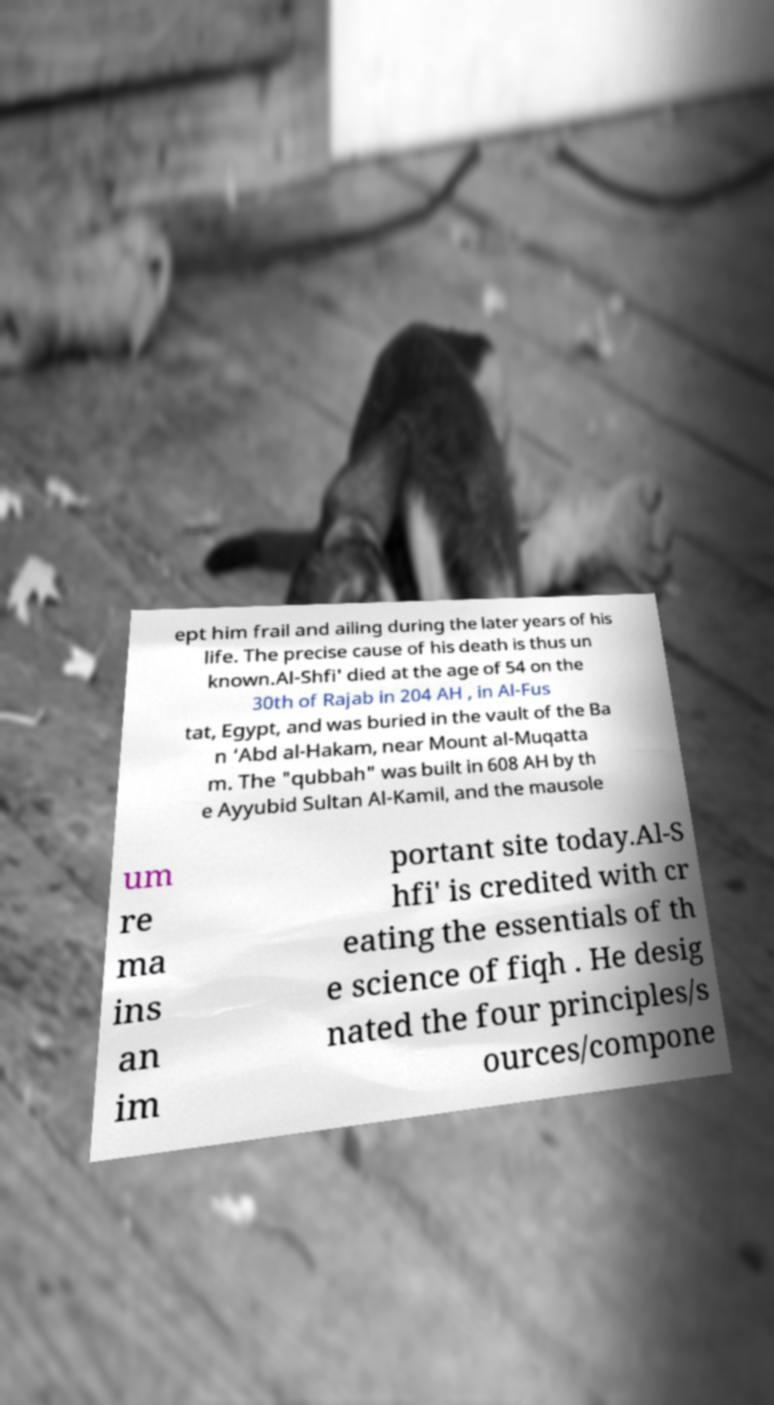For documentation purposes, I need the text within this image transcribed. Could you provide that? ept him frail and ailing during the later years of his life. The precise cause of his death is thus un known.Al-Shfi' died at the age of 54 on the 30th of Rajab in 204 AH , in Al-Fus tat, Egypt, and was buried in the vault of the Ba n ‘Abd al-Hakam, near Mount al-Muqatta m. The "qubbah" was built in 608 AH by th e Ayyubid Sultan Al-Kamil, and the mausole um re ma ins an im portant site today.Al-S hfi' is credited with cr eating the essentials of th e science of fiqh . He desig nated the four principles/s ources/compone 